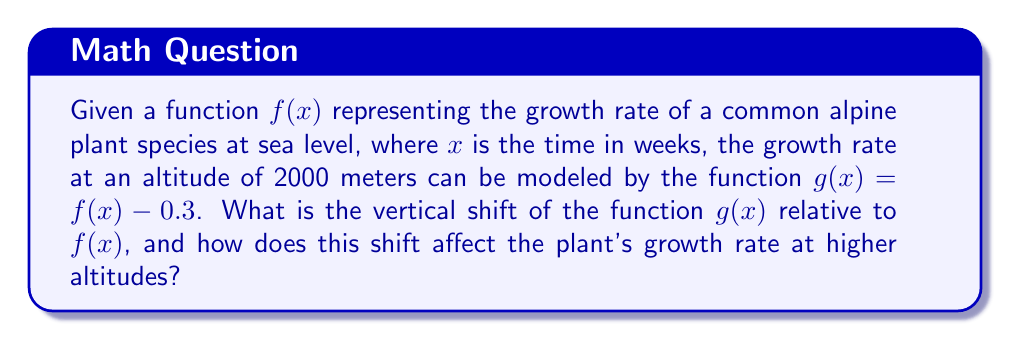Teach me how to tackle this problem. To determine the vertical shift of $g(x)$ relative to $f(x)$, we need to analyze the relationship between these two functions:

1. The given equation is $g(x) = f(x) - 0.3$

2. In general, for a vertical shift, the form is:
   $g(x) = f(x) + k$, where $k$ is the vertical shift

3. Comparing our equation to the general form, we see that $k = -0.3$

4. A negative value for $k$ indicates a downward shift

5. The magnitude of the shift is 0.3 units

6. This means that for any input $x$, the output of $g(x)$ will be 0.3 units less than the output of $f(x)$

7. In the context of plant growth, this vertical shift represents a decrease in the growth rate at higher altitudes

8. The shift of 0.3 units downward suggests that plants at 2000 meters altitude will grow more slowly than the same species at sea level, with the growth rate reduced by 0.3 units (in whatever units the original function used, e.g., cm/week)
Answer: 0.3 units downward 